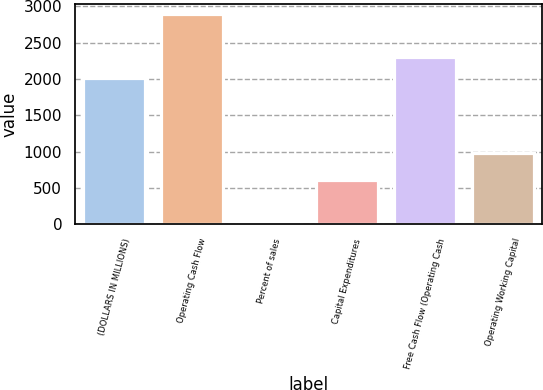Convert chart. <chart><loc_0><loc_0><loc_500><loc_500><bar_chart><fcel>(DOLLARS IN MILLIONS)<fcel>Operating Cash Flow<fcel>Percent of sales<fcel>Capital Expenditures<fcel>Free Cash Flow (Operating Cash<fcel>Operating Working Capital<nl><fcel>2018<fcel>2892<fcel>16.6<fcel>617<fcel>2305.54<fcel>985<nl></chart> 